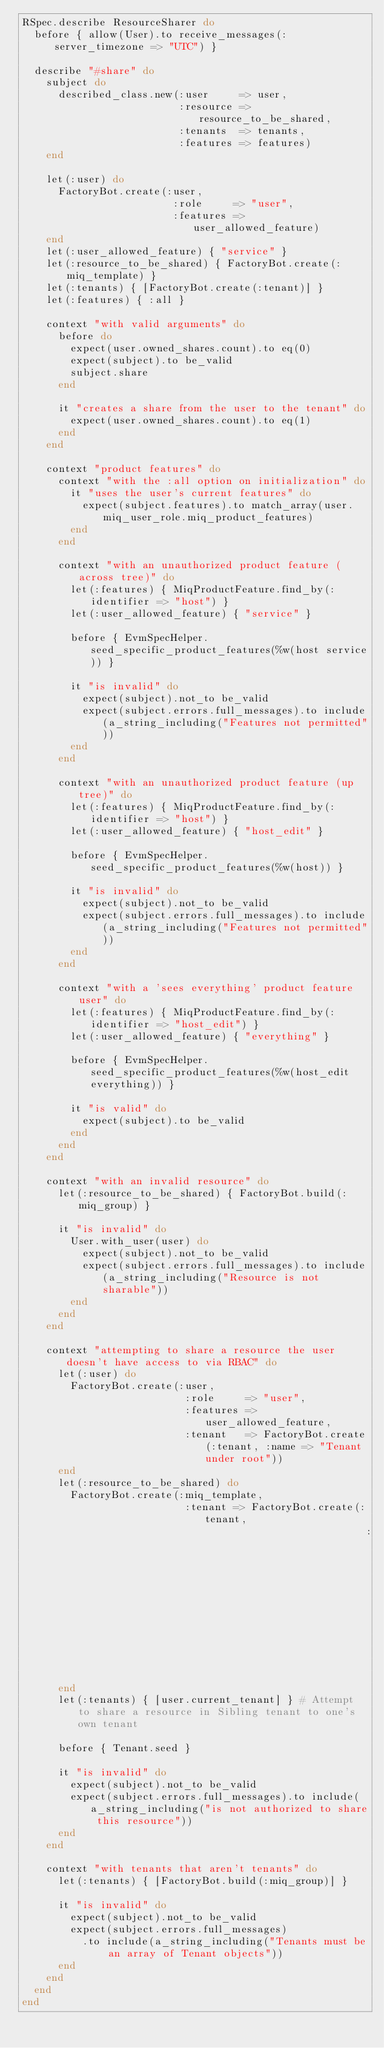Convert code to text. <code><loc_0><loc_0><loc_500><loc_500><_Ruby_>RSpec.describe ResourceSharer do
  before { allow(User).to receive_messages(:server_timezone => "UTC") }

  describe "#share" do
    subject do
      described_class.new(:user     => user,
                          :resource => resource_to_be_shared,
                          :tenants  => tenants,
                          :features => features)
    end

    let(:user) do
      FactoryBot.create(:user,
                         :role     => "user",
                         :features => user_allowed_feature)
    end
    let(:user_allowed_feature) { "service" }
    let(:resource_to_be_shared) { FactoryBot.create(:miq_template) }
    let(:tenants) { [FactoryBot.create(:tenant)] }
    let(:features) { :all }

    context "with valid arguments" do
      before do
        expect(user.owned_shares.count).to eq(0)
        expect(subject).to be_valid
        subject.share
      end

      it "creates a share from the user to the tenant" do
        expect(user.owned_shares.count).to eq(1)
      end
    end

    context "product features" do
      context "with the :all option on initialization" do
        it "uses the user's current features" do
          expect(subject.features).to match_array(user.miq_user_role.miq_product_features)
        end
      end

      context "with an unauthorized product feature (across tree)" do
        let(:features) { MiqProductFeature.find_by(:identifier => "host") }
        let(:user_allowed_feature) { "service" }

        before { EvmSpecHelper.seed_specific_product_features(%w(host service)) }

        it "is invalid" do
          expect(subject).not_to be_valid
          expect(subject.errors.full_messages).to include(a_string_including("Features not permitted"))
        end
      end

      context "with an unauthorized product feature (up tree)" do
        let(:features) { MiqProductFeature.find_by(:identifier => "host") }
        let(:user_allowed_feature) { "host_edit" }

        before { EvmSpecHelper.seed_specific_product_features(%w(host)) }

        it "is invalid" do
          expect(subject).not_to be_valid
          expect(subject.errors.full_messages).to include(a_string_including("Features not permitted"))
        end
      end

      context "with a 'sees everything' product feature user" do
        let(:features) { MiqProductFeature.find_by(:identifier => "host_edit") }
        let(:user_allowed_feature) { "everything" }

        before { EvmSpecHelper.seed_specific_product_features(%w(host_edit everything)) }

        it "is valid" do
          expect(subject).to be_valid
        end
      end
    end

    context "with an invalid resource" do
      let(:resource_to_be_shared) { FactoryBot.build(:miq_group) }

      it "is invalid" do
        User.with_user(user) do
          expect(subject).not_to be_valid
          expect(subject.errors.full_messages).to include(a_string_including("Resource is not sharable"))
        end
      end
    end

    context "attempting to share a resource the user doesn't have access to via RBAC" do
      let(:user) do
        FactoryBot.create(:user,
                           :role     => "user",
                           :features => user_allowed_feature,
                           :tenant   => FactoryBot.create(:tenant, :name => "Tenant under root"))
      end
      let(:resource_to_be_shared) do
        FactoryBot.create(:miq_template,
                           :tenant => FactoryBot.create(:tenant,
                                                         :name => "Sibling tenant"))
      end
      let(:tenants) { [user.current_tenant] } # Attempt to share a resource in Sibling tenant to one's own tenant

      before { Tenant.seed }

      it "is invalid" do
        expect(subject).not_to be_valid
        expect(subject.errors.full_messages).to include(a_string_including("is not authorized to share this resource"))
      end
    end

    context "with tenants that aren't tenants" do
      let(:tenants) { [FactoryBot.build(:miq_group)] }

      it "is invalid" do
        expect(subject).not_to be_valid
        expect(subject.errors.full_messages)
          .to include(a_string_including("Tenants must be an array of Tenant objects"))
      end
    end
  end
end
</code> 